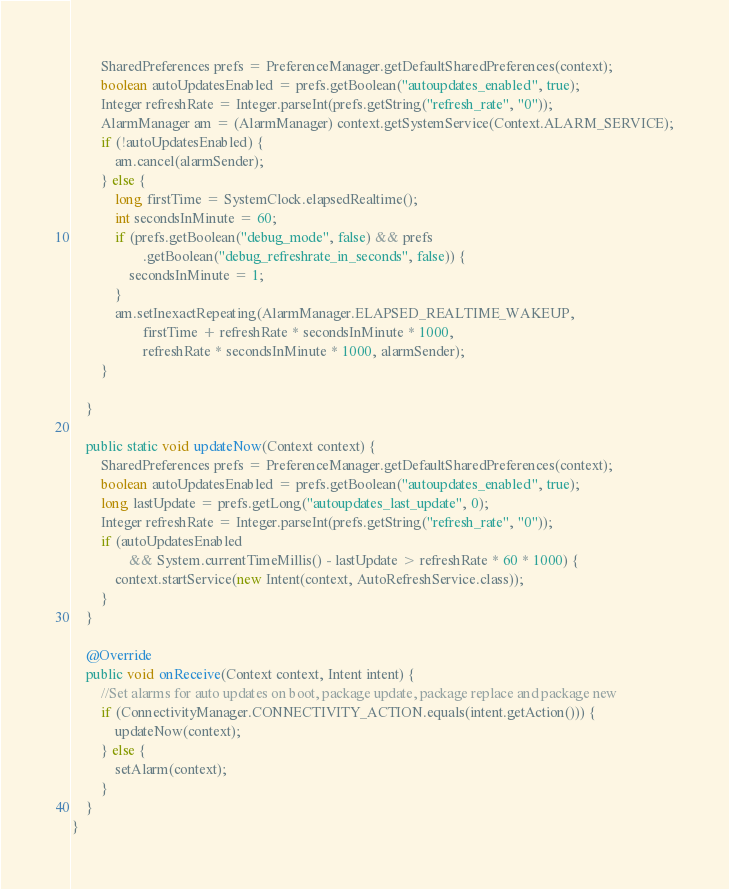<code> <loc_0><loc_0><loc_500><loc_500><_Java_>        SharedPreferences prefs = PreferenceManager.getDefaultSharedPreferences(context);
        boolean autoUpdatesEnabled = prefs.getBoolean("autoupdates_enabled", true);
        Integer refreshRate = Integer.parseInt(prefs.getString("refresh_rate", "0"));
        AlarmManager am = (AlarmManager) context.getSystemService(Context.ALARM_SERVICE);
        if (!autoUpdatesEnabled) {
            am.cancel(alarmSender);
        } else {
            long firstTime = SystemClock.elapsedRealtime();
            int secondsInMinute = 60;
            if (prefs.getBoolean("debug_mode", false) && prefs
                    .getBoolean("debug_refreshrate_in_seconds", false)) {
                secondsInMinute = 1;
            }
            am.setInexactRepeating(AlarmManager.ELAPSED_REALTIME_WAKEUP,
                    firstTime + refreshRate * secondsInMinute * 1000,
                    refreshRate * secondsInMinute * 1000, alarmSender);
        }

    }

    public static void updateNow(Context context) {
        SharedPreferences prefs = PreferenceManager.getDefaultSharedPreferences(context);
        boolean autoUpdatesEnabled = prefs.getBoolean("autoupdates_enabled", true);
        long lastUpdate = prefs.getLong("autoupdates_last_update", 0);
        Integer refreshRate = Integer.parseInt(prefs.getString("refresh_rate", "0"));
        if (autoUpdatesEnabled
                && System.currentTimeMillis() - lastUpdate > refreshRate * 60 * 1000) {
            context.startService(new Intent(context, AutoRefreshService.class));
        }
    }

    @Override
    public void onReceive(Context context, Intent intent) {
        //Set alarms for auto updates on boot, package update, package replace and package new
        if (ConnectivityManager.CONNECTIVITY_ACTION.equals(intent.getAction())) {
            updateNow(context);
        } else {
            setAlarm(context);
        }
    }
}
</code> 